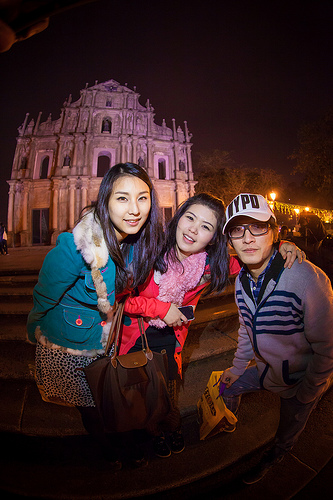<image>
Is the man under the woman? No. The man is not positioned under the woman. The vertical relationship between these objects is different. 